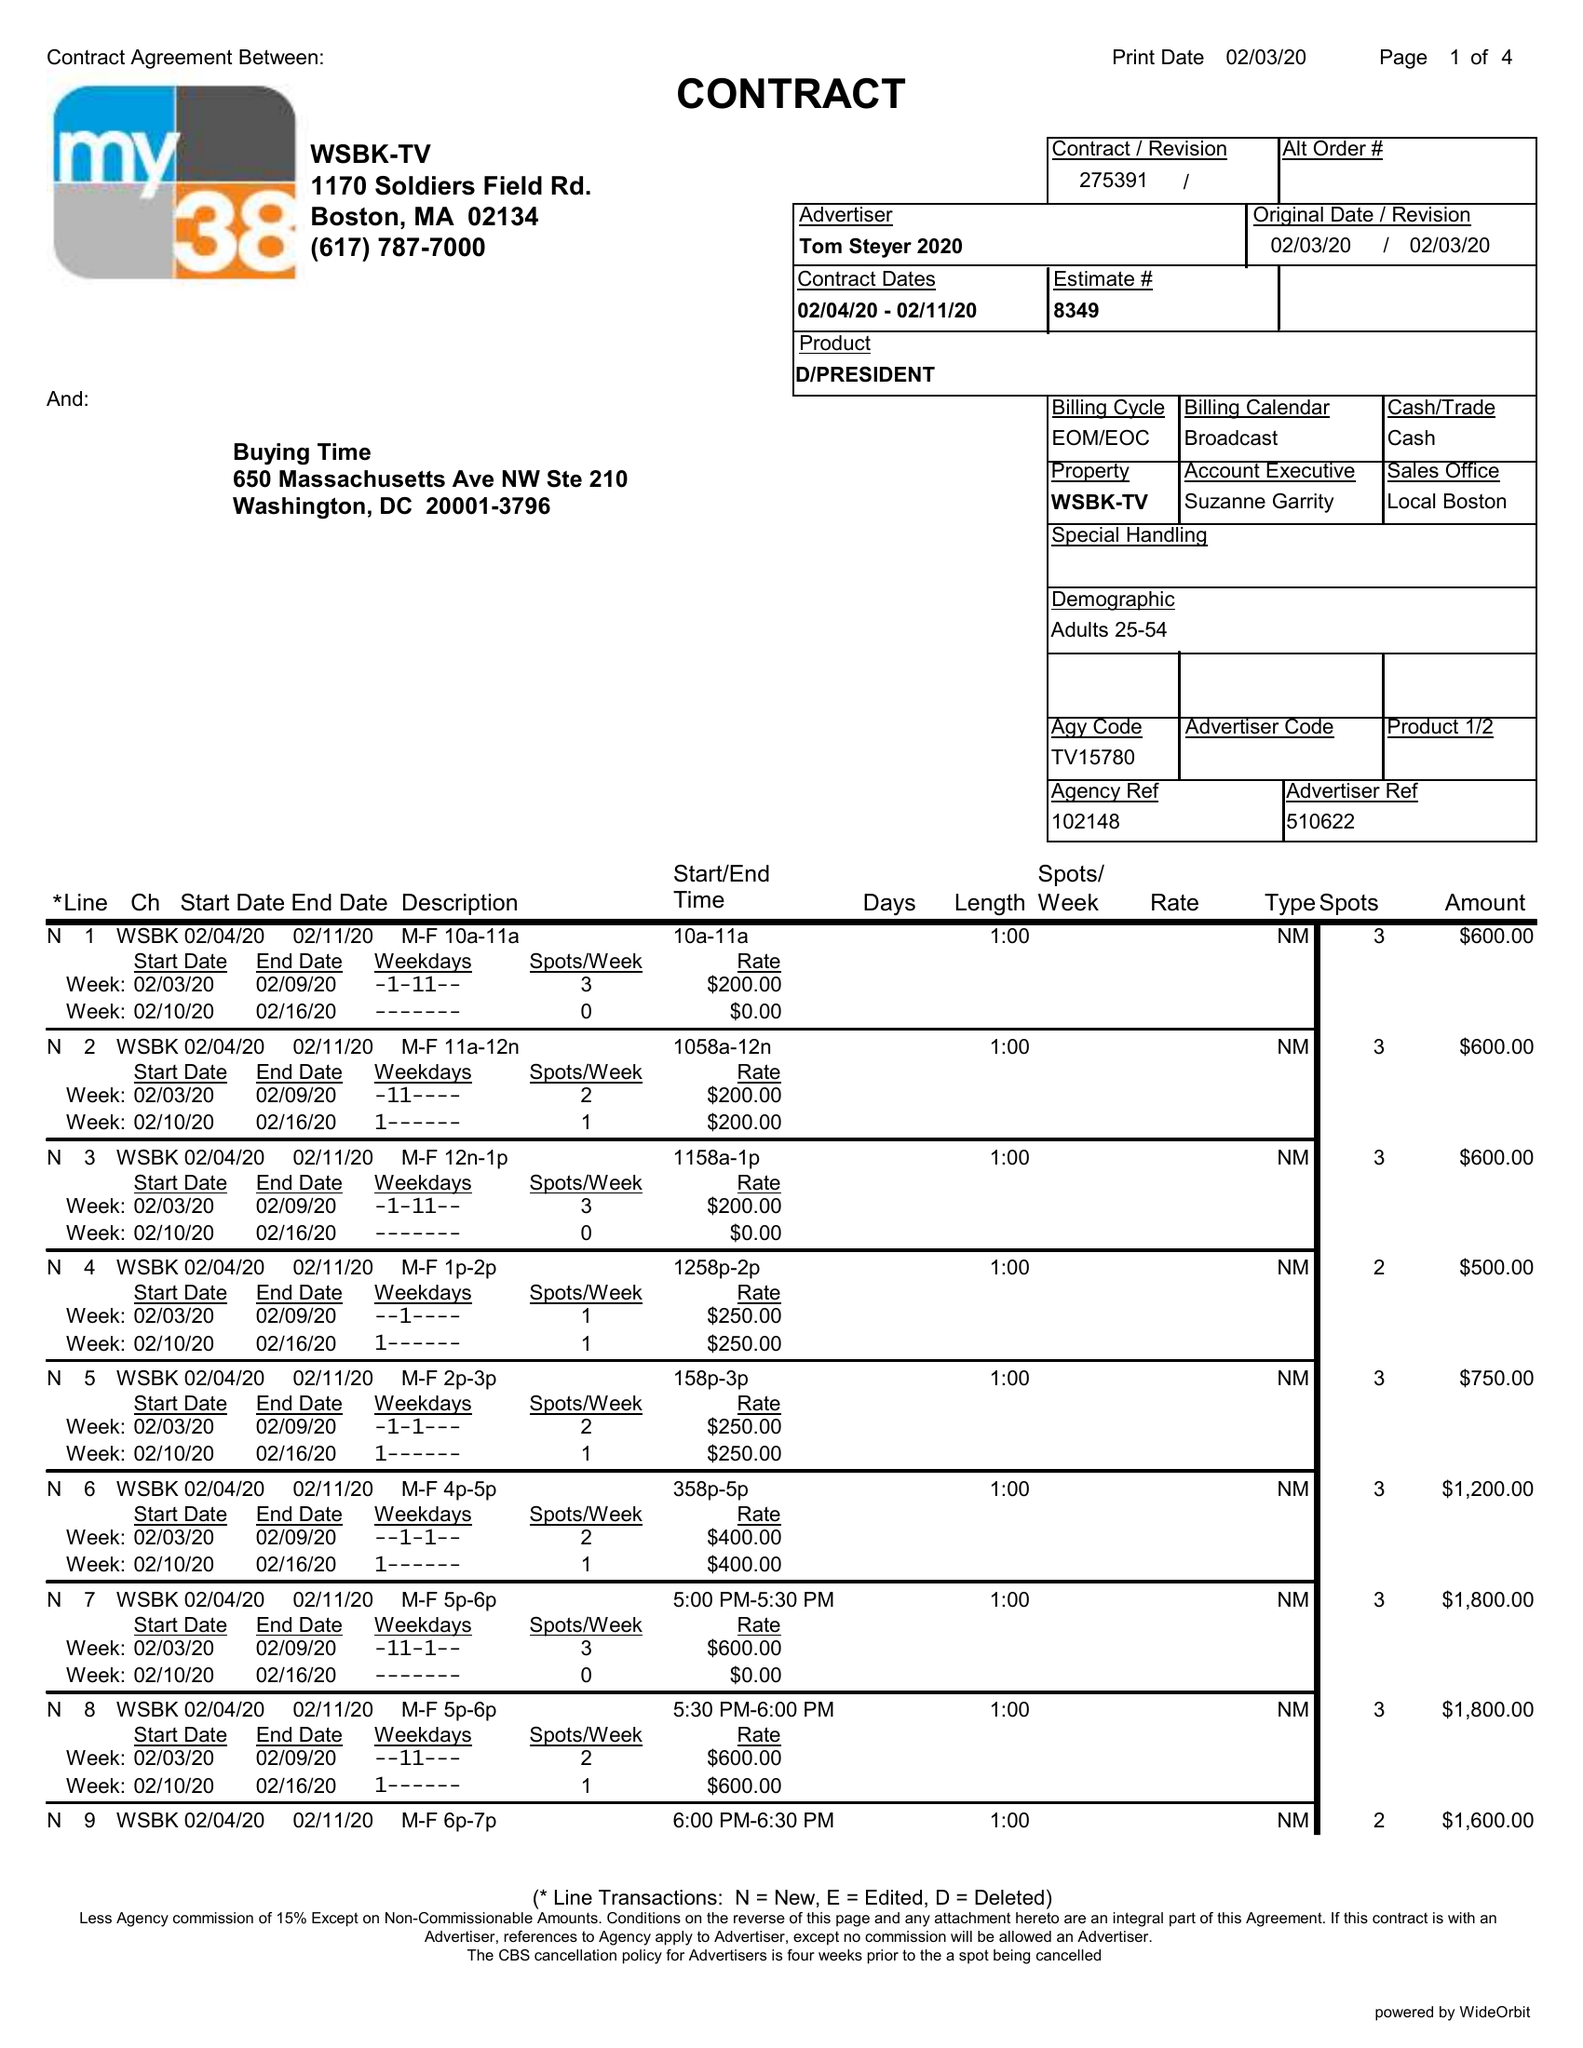What is the value for the flight_from?
Answer the question using a single word or phrase. 02/04/20 